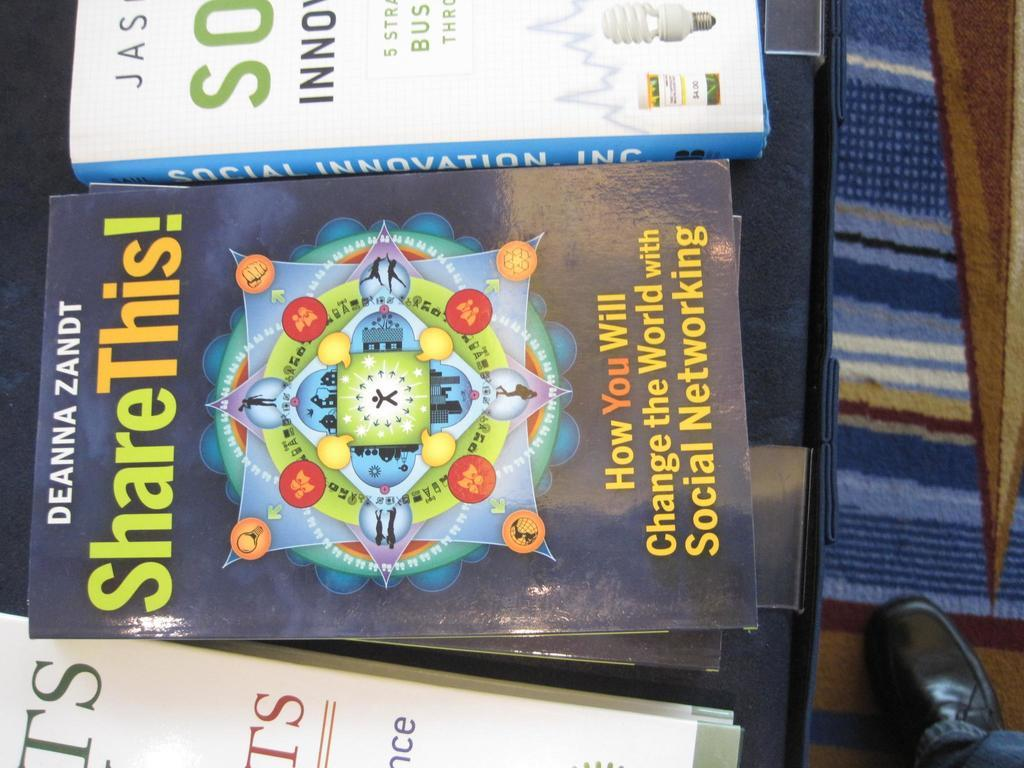What objects are on the table in the image? There are books on the table in the image. What other item can be seen in the image besides the books? There is a person's shoe in the image. What type of animals can be seen at the zoo in the image? There is no zoo present in the image; it only features books on a table and a person's shoe. How tall are the giants in the image? There are no giants present in the image. 